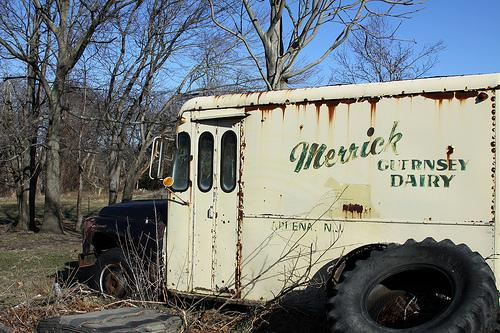Question: where is the truck?
Choices:
A. In a parking lot.
B. In a garage.
C. Outdoors in semi wooded area.
D. On the street.
Answer with the letter. Answer: C Question: what is the color of the sign on the truck?
Choices:
A. Green.
B. Red.
C. Blue.
D. White.
Answer with the letter. Answer: A Question: who is in this picture?
Choices:
A. Woman.
B. Man.
C. Girl.
D. Nobody.
Answer with the letter. Answer: D Question: how is it outside?
Choices:
A. Rainy.
B. Cloudy.
C. Bright and nice.
D. Snowy.
Answer with the letter. Answer: C 